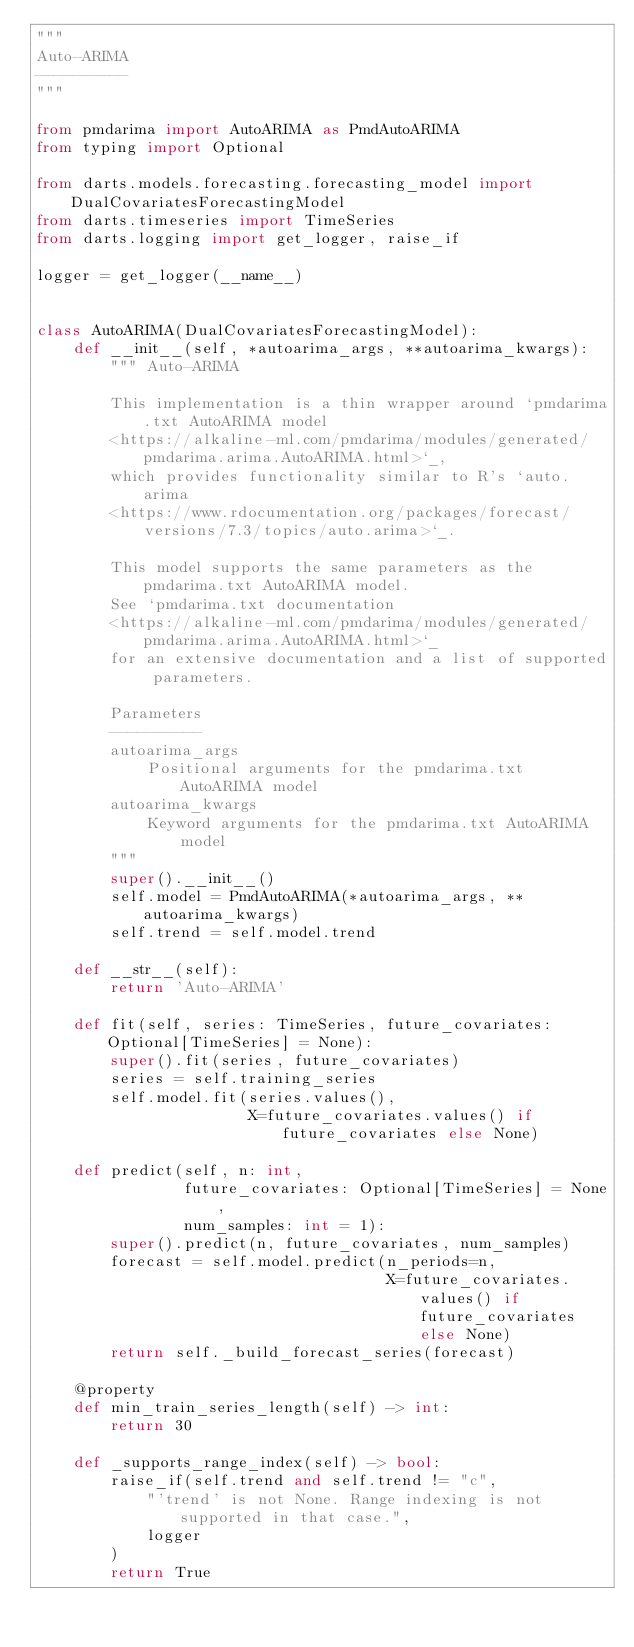Convert code to text. <code><loc_0><loc_0><loc_500><loc_500><_Python_>"""
Auto-ARIMA
----------
"""

from pmdarima import AutoARIMA as PmdAutoARIMA
from typing import Optional

from darts.models.forecasting.forecasting_model import DualCovariatesForecastingModel
from darts.timeseries import TimeSeries
from darts.logging import get_logger, raise_if

logger = get_logger(__name__)


class AutoARIMA(DualCovariatesForecastingModel):
    def __init__(self, *autoarima_args, **autoarima_kwargs):
        """ Auto-ARIMA

        This implementation is a thin wrapper around `pmdarima.txt AutoARIMA model
        <https://alkaline-ml.com/pmdarima/modules/generated/pmdarima.arima.AutoARIMA.html>`_,
        which provides functionality similar to R's `auto.arima
        <https://www.rdocumentation.org/packages/forecast/versions/7.3/topics/auto.arima>`_.

        This model supports the same parameters as the pmdarima.txt AutoARIMA model.
        See `pmdarima.txt documentation
        <https://alkaline-ml.com/pmdarima/modules/generated/pmdarima.arima.AutoARIMA.html>`_
        for an extensive documentation and a list of supported parameters.

        Parameters
        ----------
        autoarima_args
            Positional arguments for the pmdarima.txt AutoARIMA model
        autoarima_kwargs
            Keyword arguments for the pmdarima.txt AutoARIMA model
        """
        super().__init__()
        self.model = PmdAutoARIMA(*autoarima_args, **autoarima_kwargs)
        self.trend = self.model.trend

    def __str__(self):
        return 'Auto-ARIMA'

    def fit(self, series: TimeSeries, future_covariates: Optional[TimeSeries] = None):
        super().fit(series, future_covariates)
        series = self.training_series
        self.model.fit(series.values(),
                       X=future_covariates.values() if future_covariates else None)

    def predict(self, n: int,
                future_covariates: Optional[TimeSeries] = None,
                num_samples: int = 1):
        super().predict(n, future_covariates, num_samples)
        forecast = self.model.predict(n_periods=n,
                                      X=future_covariates.values() if future_covariates else None)
        return self._build_forecast_series(forecast)

    @property
    def min_train_series_length(self) -> int:
        return 30

    def _supports_range_index(self) -> bool:
        raise_if(self.trend and self.trend != "c",
            "'trend' is not None. Range indexing is not supported in that case.",
            logger
        )
        return True
</code> 